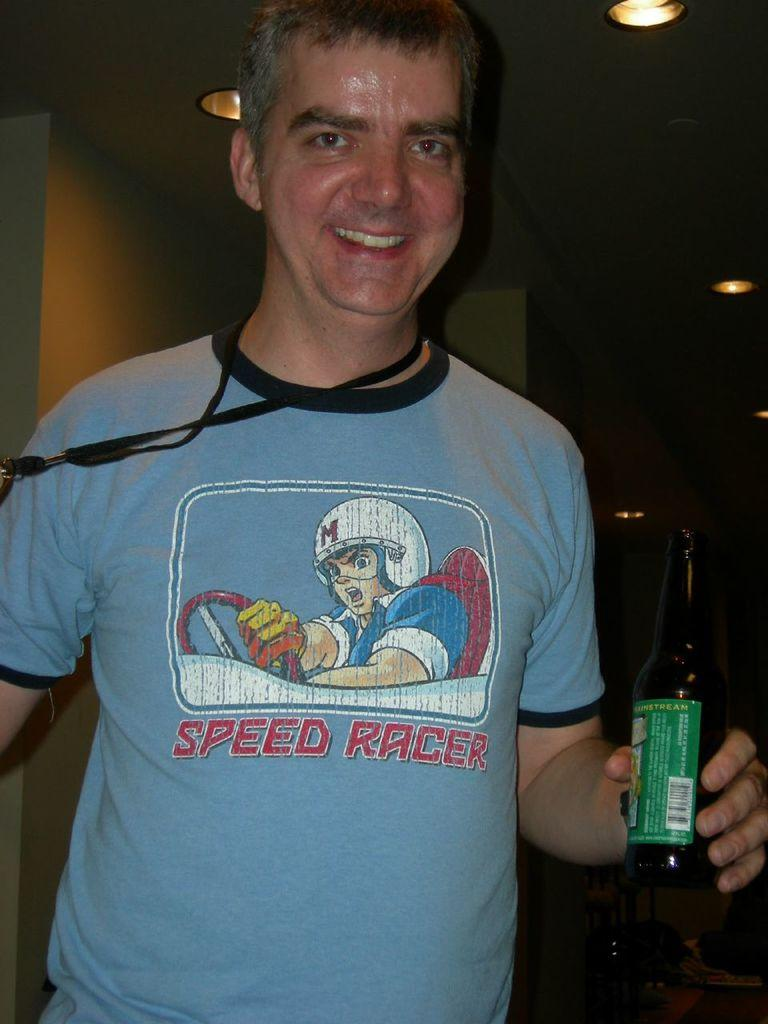Who is the main subject in the image? There is a man in the image. Where is the man located in the image? The man is at the center of the image. What is the man holding in his hand? The man is holding a bottle in his hand. What can be seen above the ceiling in the image? There are lights above the ceiling in the image. What time of day is depicted in the image? The image depicts a night time scene. How many flocks of birds are flying in the image? There are no birds or flocks visible in the image. What type of waste is present in the image? There is no waste present in the image. 